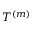Convert formula to latex. <formula><loc_0><loc_0><loc_500><loc_500>T ^ { ( m ) }</formula> 